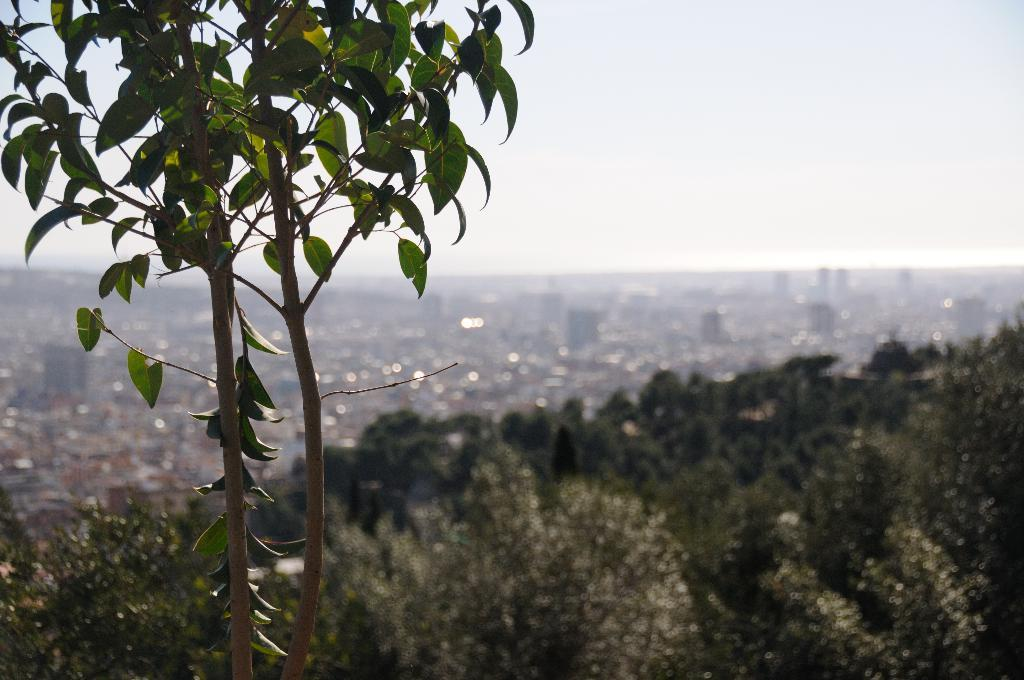What type of natural elements can be seen in the image? There are trees in the image. What type of man-made structures are present in the image? There are buildings in the image, but they are blurred. What part of the natural environment is visible in the image? The sky is visible in the background of the image. What type of lunch is being served at the feast in the image? There is no mention of a feast or lunch in the image; it features trees and blurred buildings. What is the primary interest of the people in the image? There are no people present in the image, so it is impossible to determine their primary interest. 